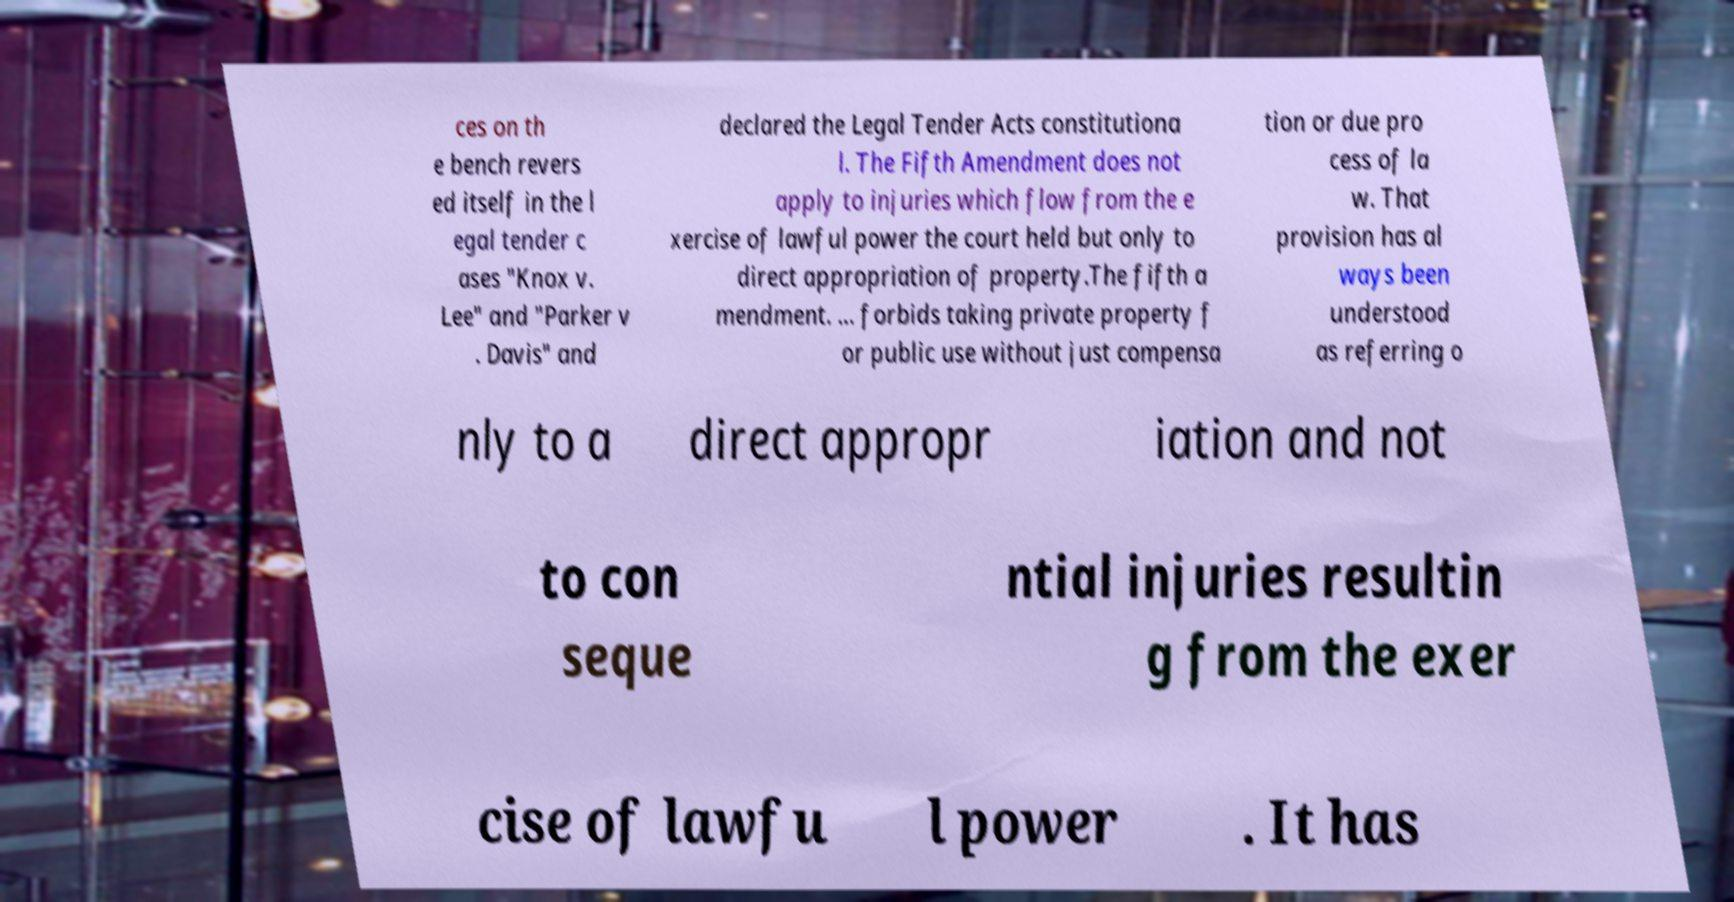Can you accurately transcribe the text from the provided image for me? ces on th e bench revers ed itself in the l egal tender c ases "Knox v. Lee" and "Parker v . Davis" and declared the Legal Tender Acts constitutiona l. The Fifth Amendment does not apply to injuries which flow from the e xercise of lawful power the court held but only to direct appropriation of property.The fifth a mendment. ... forbids taking private property f or public use without just compensa tion or due pro cess of la w. That provision has al ways been understood as referring o nly to a direct appropr iation and not to con seque ntial injuries resultin g from the exer cise of lawfu l power . It has 